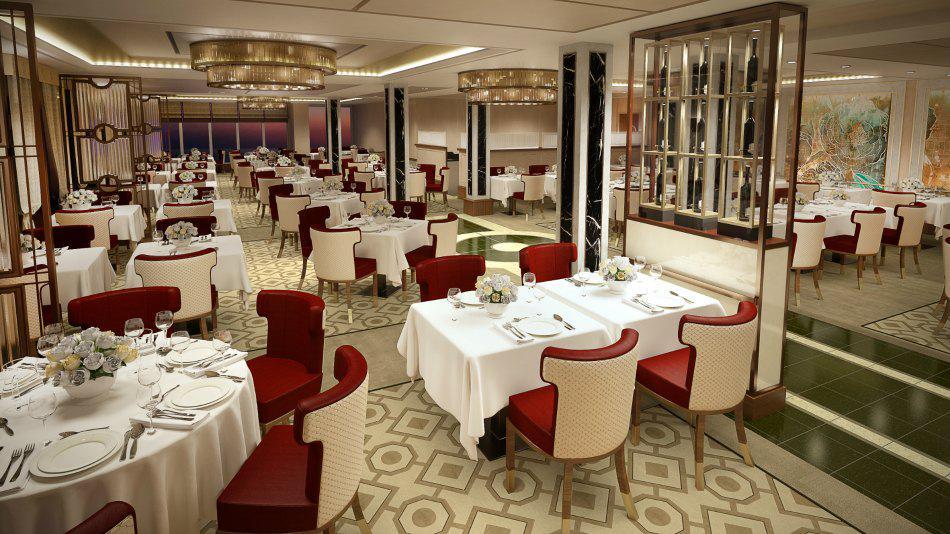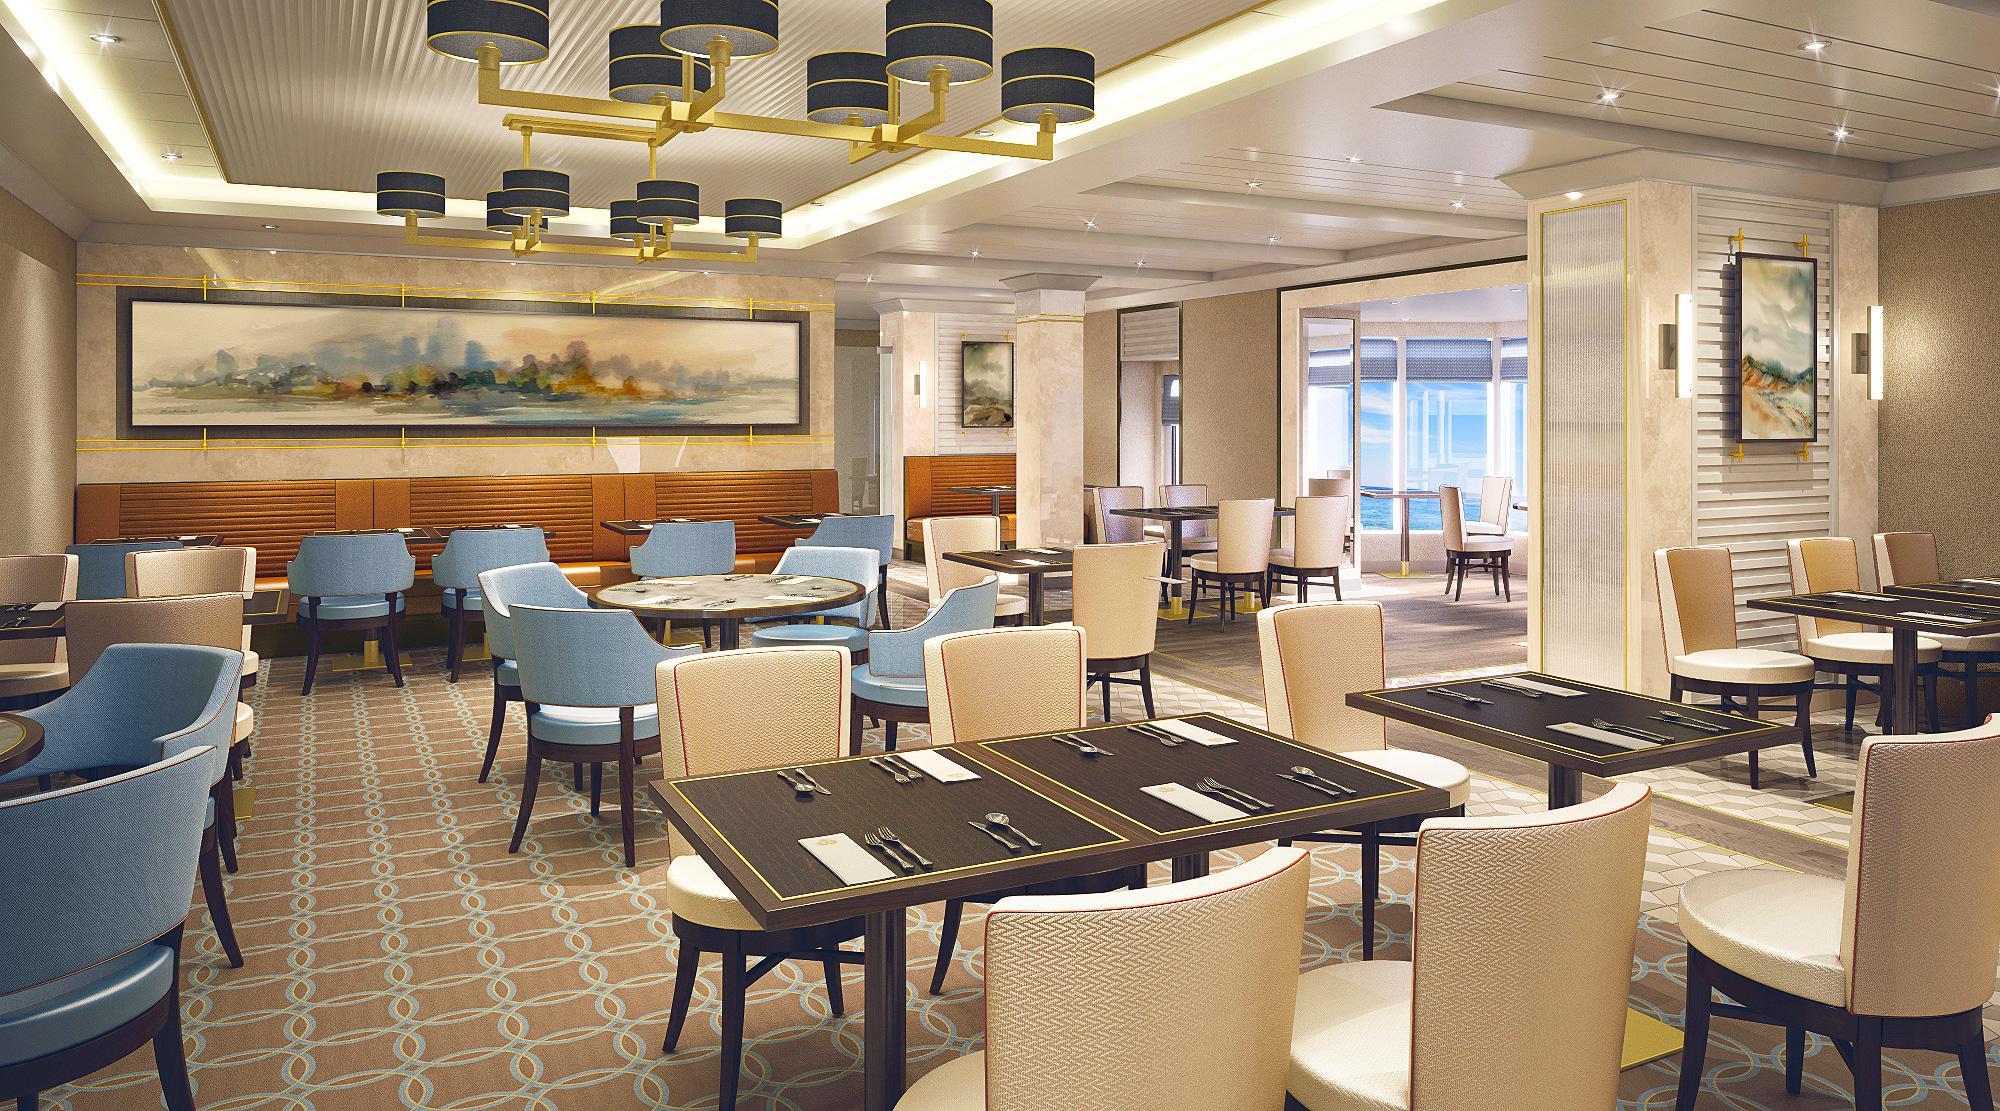The first image is the image on the left, the second image is the image on the right. Assess this claim about the two images: "One of the images has chairs with red upholstery and white backs.". Correct or not? Answer yes or no. Yes. The first image is the image on the left, the second image is the image on the right. Analyze the images presented: Is the assertion "There is a large skylight visible in at least one of the images." valid? Answer yes or no. No. 